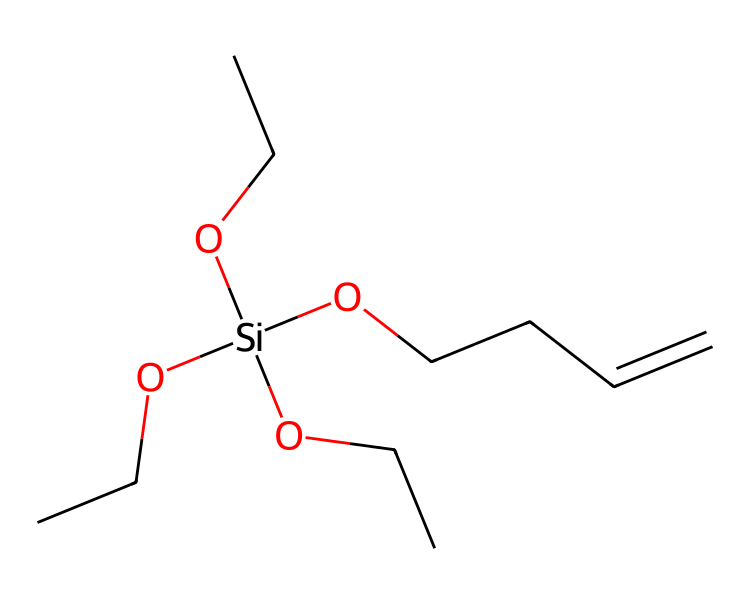What is the primary functional group in this molecule? The molecule contains hydroxyl groups (–OH) attached to the silicon atom, which are indicative of silanol groups. These hydroxyl groups are key functional components in organosilicon compounds.
Answer: hydroxyl How many silicon atoms are present in the structure? The structure shows one silicon atom connected to multiple substituents, which can be identified by the presence of the '[Si]' in the SMILES representation, indicating a single silicon atom.
Answer: one What type of carbon chain is present in this compound? Analyzing the carbon chain in the side groups, there's a double bond (CCC=C) indicative of an alkene, combined with linear alkane chains (OCC) further suggest a carbon-containing organic chain component.
Answer: alkene What is the role of silane coupling agents in tire manufacturing? Silane coupling agents improve adhesion between the rubber matrix and fillers such as silica in tires, enhancing tire performance, durability, and grip. This bond is facilitated by the silanol groups present in the compound.
Answer: adhesion Which type of polymer does this chemical structure typically enhance? The presence of silane coupling agents effectively enhances the properties of silica-reinforced rubber polymers in tire manufacturing, by improving the interface between the silica filler and rubber matrix.
Answer: silica-reinforced rubber How many oxygen atoms are present in the structure? By inspecting the SMILES notation, there are four 'O' characters, indicating four oxygen atoms are actively involved in the molecular structure of the compound.
Answer: four 